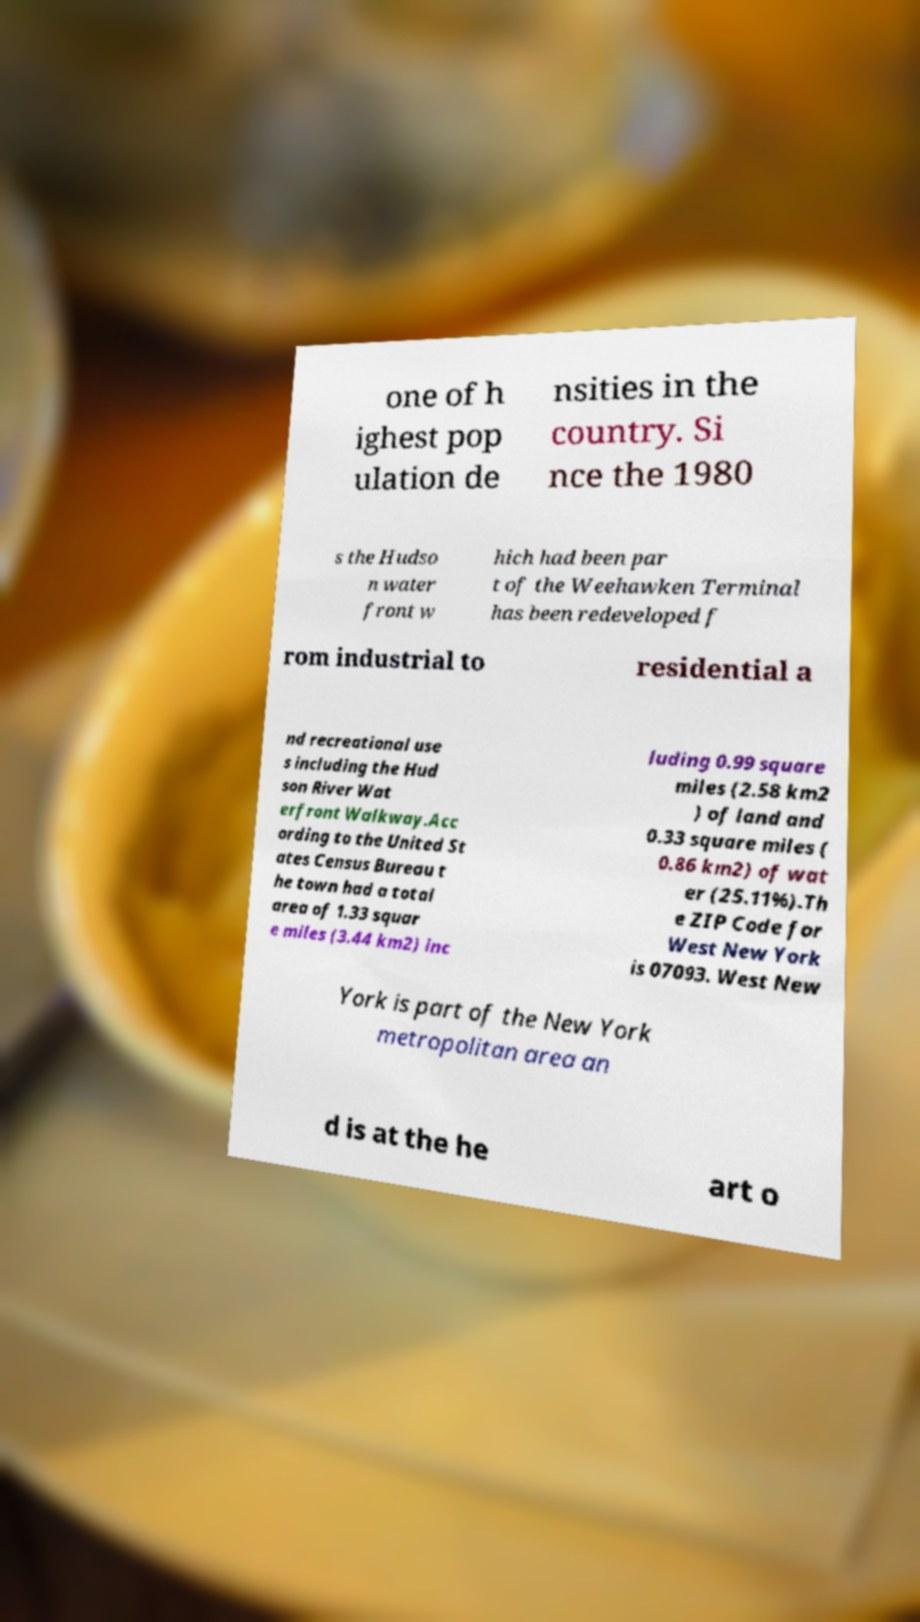Can you read and provide the text displayed in the image?This photo seems to have some interesting text. Can you extract and type it out for me? one of h ighest pop ulation de nsities in the country. Si nce the 1980 s the Hudso n water front w hich had been par t of the Weehawken Terminal has been redeveloped f rom industrial to residential a nd recreational use s including the Hud son River Wat erfront Walkway.Acc ording to the United St ates Census Bureau t he town had a total area of 1.33 squar e miles (3.44 km2) inc luding 0.99 square miles (2.58 km2 ) of land and 0.33 square miles ( 0.86 km2) of wat er (25.11%).Th e ZIP Code for West New York is 07093. West New York is part of the New York metropolitan area an d is at the he art o 